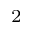Convert formula to latex. <formula><loc_0><loc_0><loc_500><loc_500>^ { 2 }</formula> 